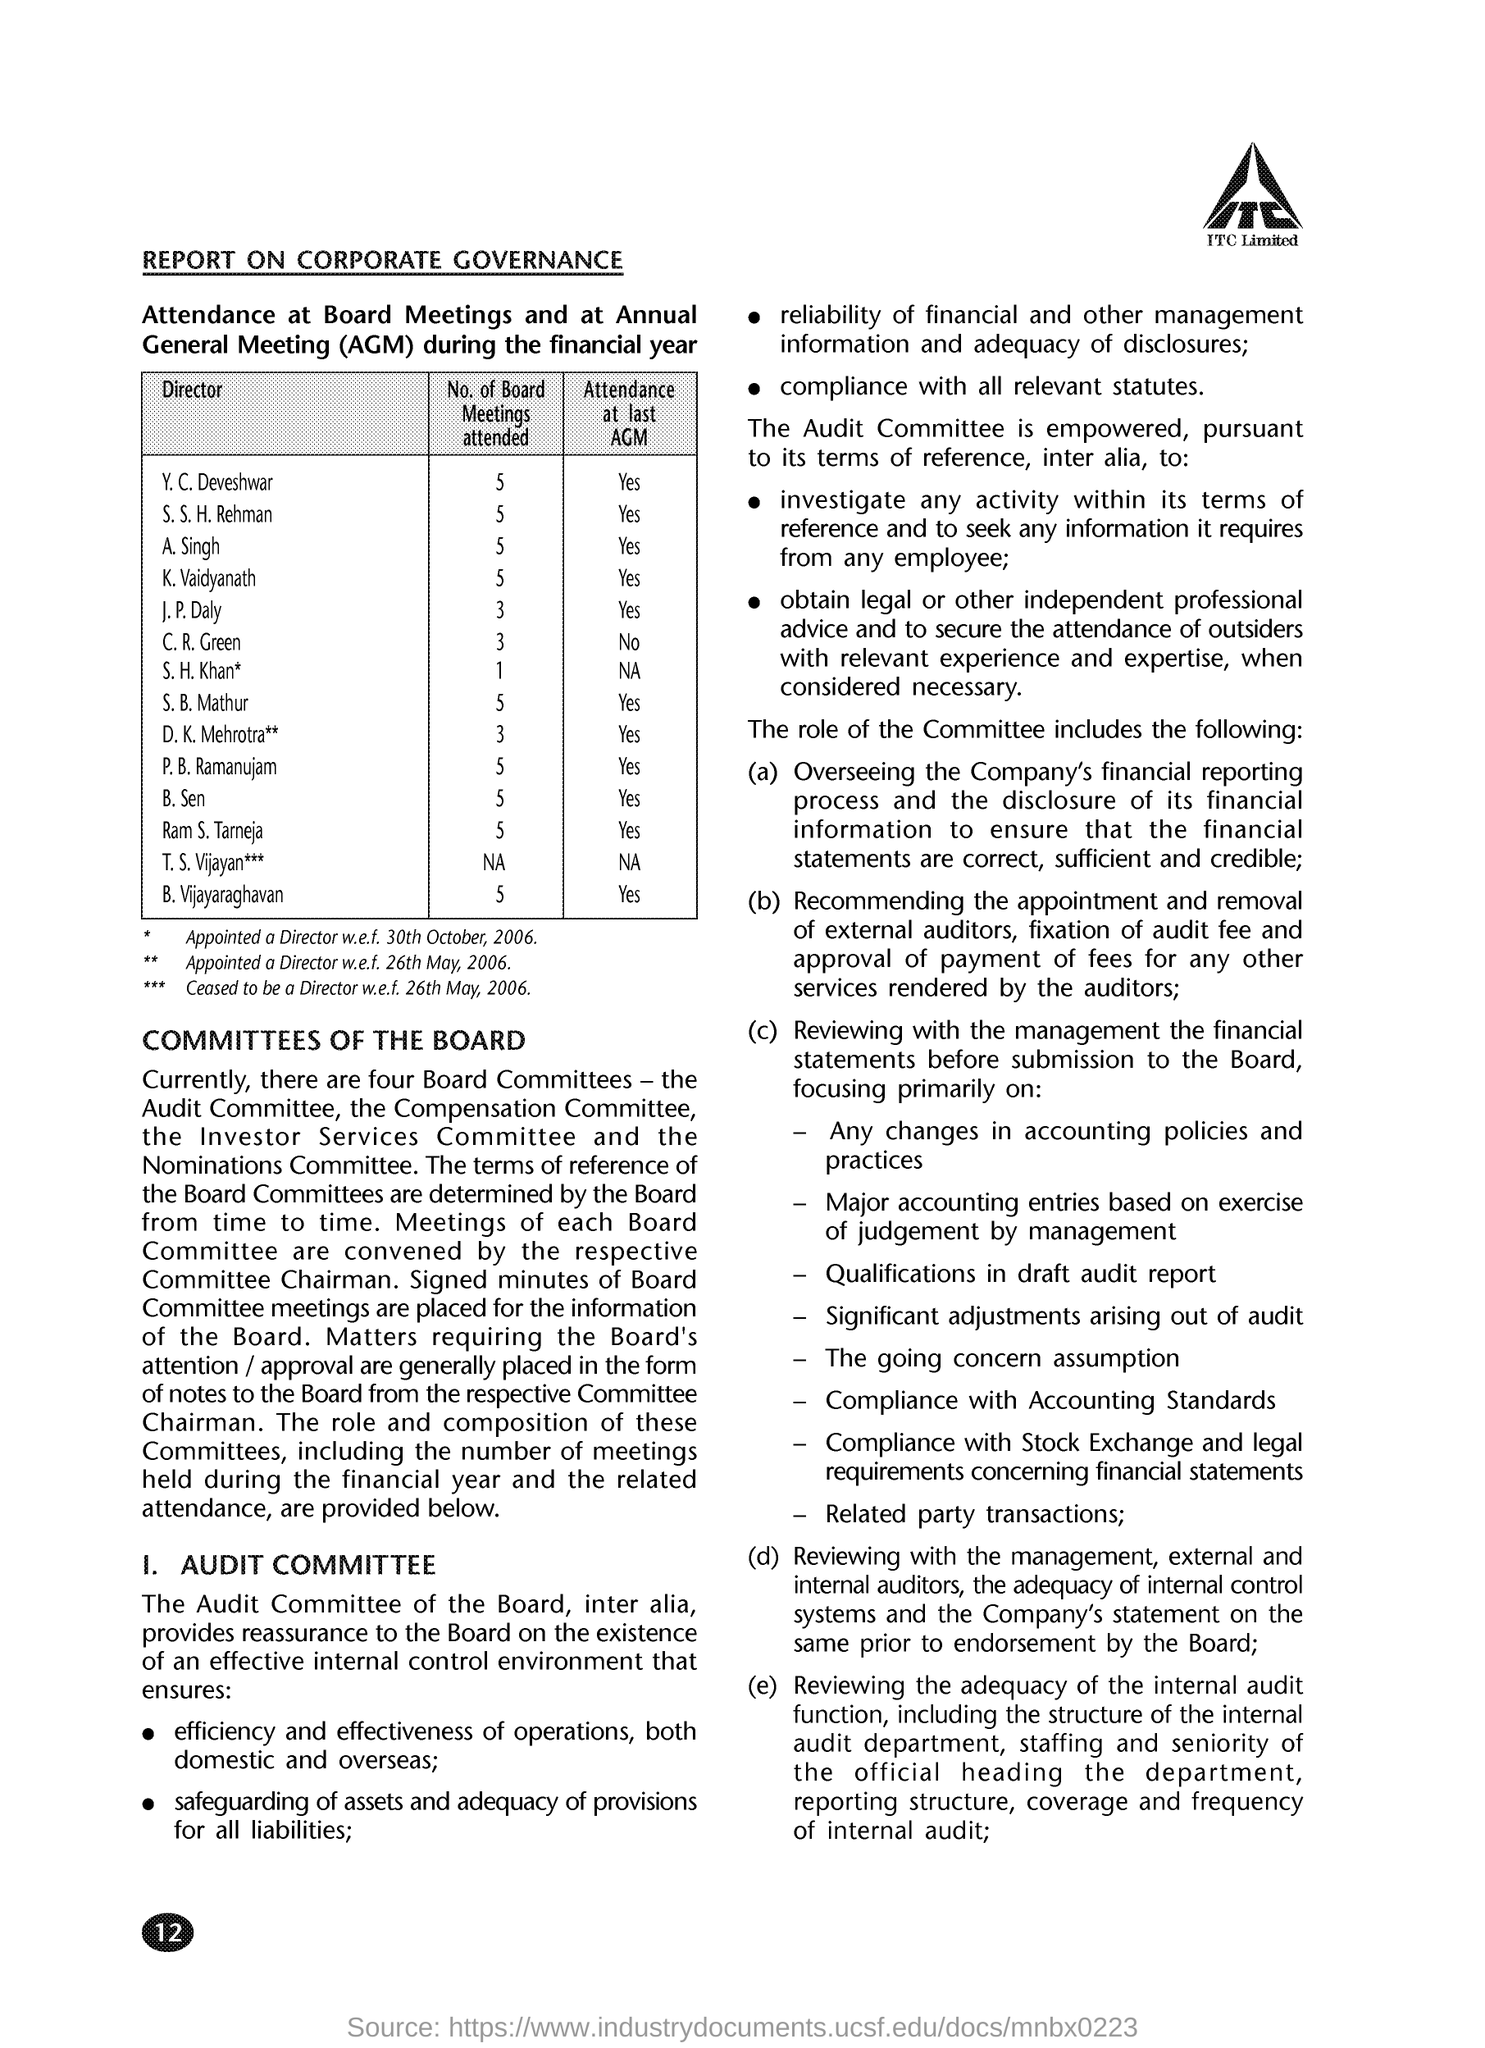List a handful of essential elements in this visual. AGM stands for Annual General Meeting. S.B. Mathur has attended 5 board meetings. There are currently four Board Committees in existence. Y. C. Deveshvar attended the last AGM. 